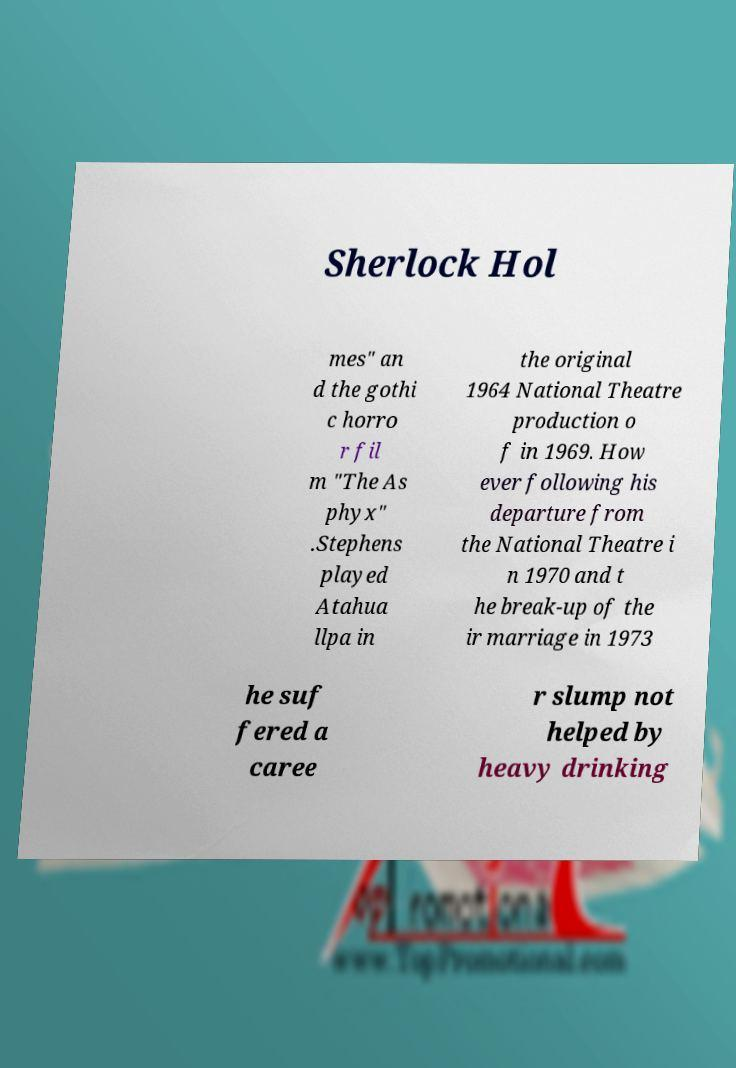There's text embedded in this image that I need extracted. Can you transcribe it verbatim? Sherlock Hol mes" an d the gothi c horro r fil m "The As phyx" .Stephens played Atahua llpa in the original 1964 National Theatre production o f in 1969. How ever following his departure from the National Theatre i n 1970 and t he break-up of the ir marriage in 1973 he suf fered a caree r slump not helped by heavy drinking 